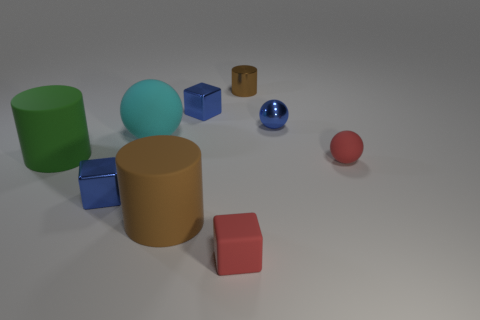Can you tell me what the different shapes in the image are? Certainly! The image showcases a variety of geometric shapes: a large green cylinder, a large cyan cylinder, a small blue sphere, a small red sphere, two small blue cubes, and a small brown cylinder.  Do the objects exhibit any particular lighting or shadows? Yes, the objects are displayed with subtle shadows that suggest a light source coming from the top left. The shadows help provide a sense of depth and position of the objects in the space. 